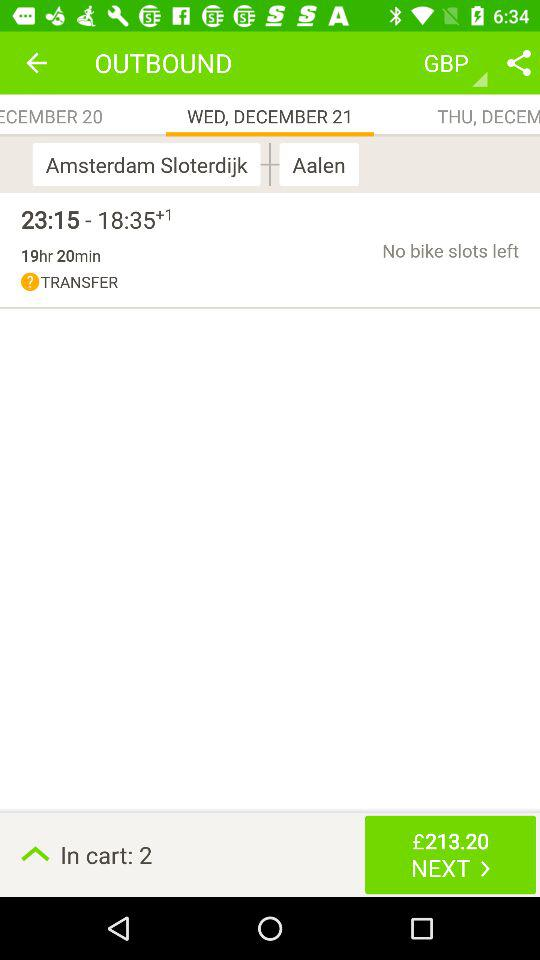What is the name of the place? The names of the places are "Amsterdam Sloterdijk" and "Aalen". 